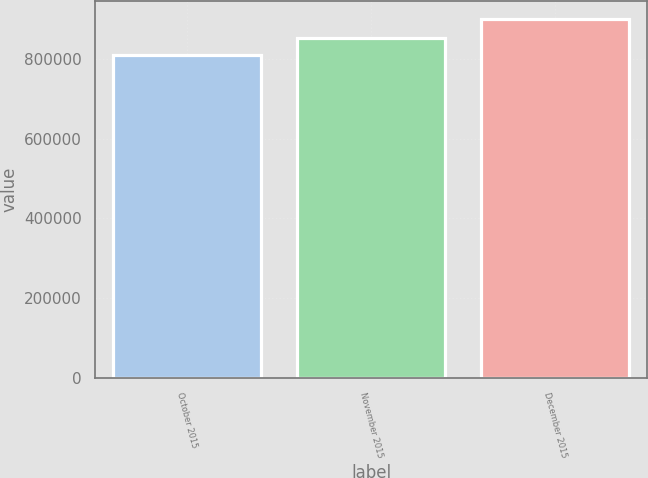<chart> <loc_0><loc_0><loc_500><loc_500><bar_chart><fcel>October 2015<fcel>November 2015<fcel>December 2015<nl><fcel>810000<fcel>854900<fcel>900800<nl></chart> 